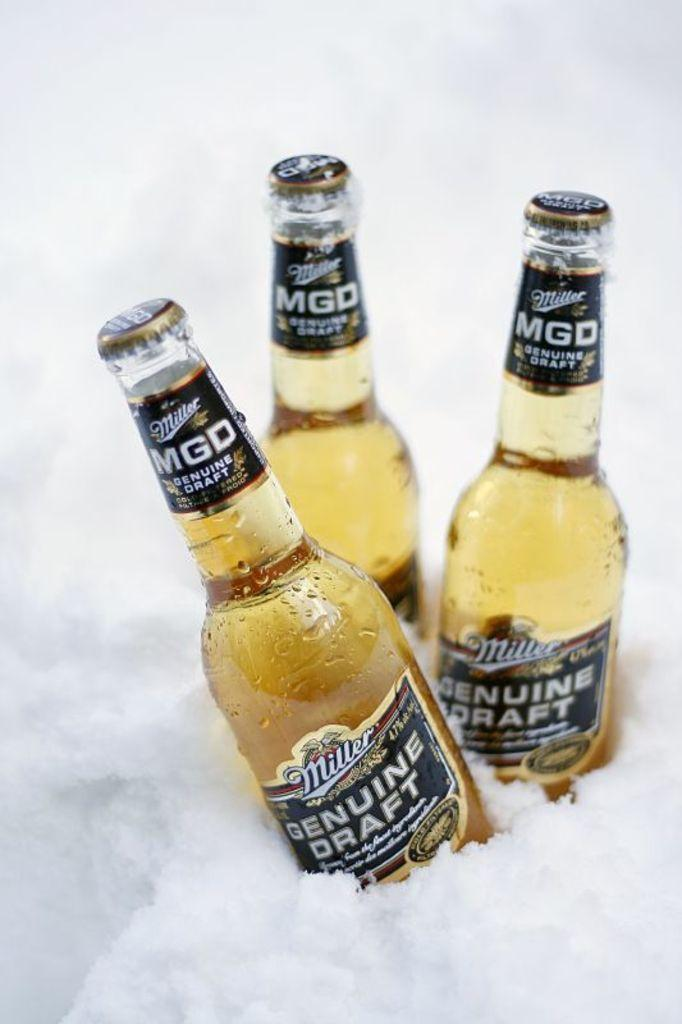<image>
Render a clear and concise summary of the photo. Three bottles of Miller Genuine draft in ice 